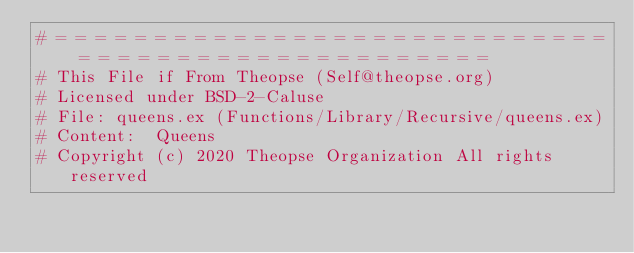<code> <loc_0><loc_0><loc_500><loc_500><_Elixir_># = = = = = = = = = = = = = = = = = = = = = = = = = = = = = = = = = = = = = = = = = = = = = = = = =
# This File if From Theopse (Self@theopse.org)
# Licensed under BSD-2-Caluse
# File:	queens.ex (Functions/Library/Recursive/queens.ex)
# Content:	Queens
# Copyright (c) 2020 Theopse Organization All rights reserved</code> 